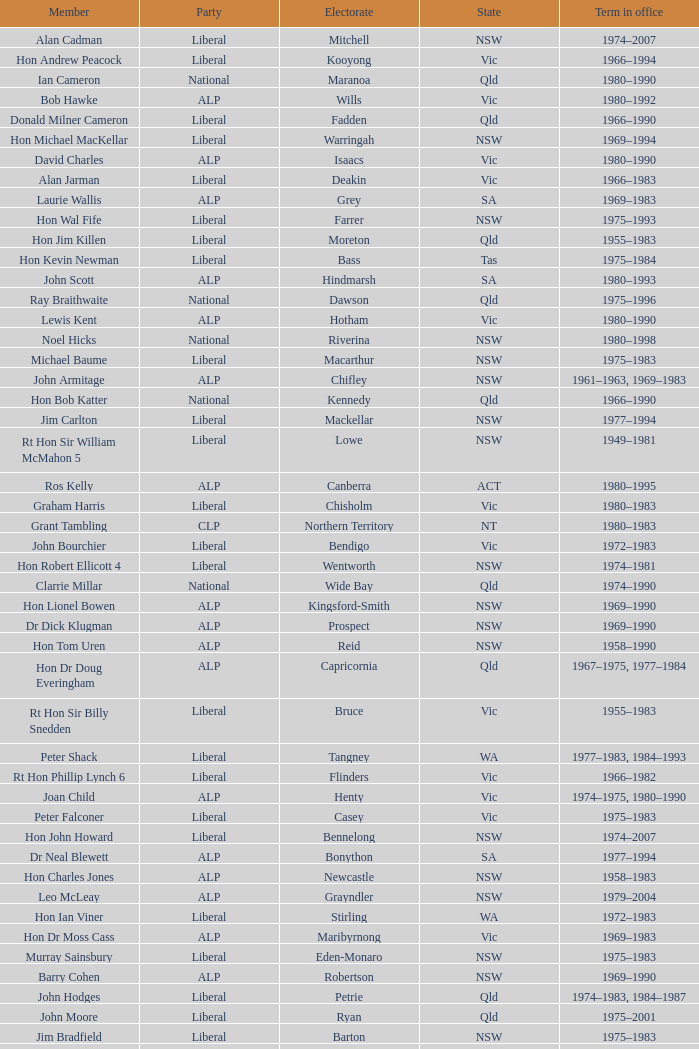Which party had a member from the state of Vic and an Electorate called Wannon? Liberal. 